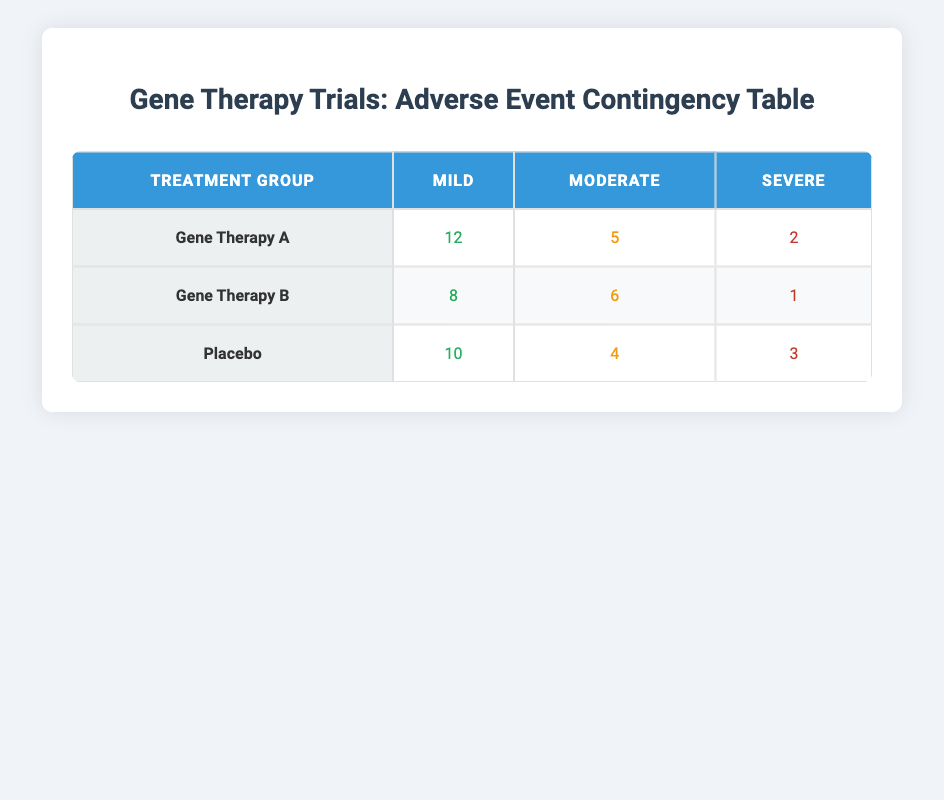What is the total number of mild adverse events in Gene Therapy A? Under the treatment group "Gene Therapy A," the table shows that the count of mild adverse events is 12. Therefore, the total number of mild adverse events for this treatment is simply the listed value of 12.
Answer: 12 Which treatment group had the highest number of severe adverse events? In the table, we see that Gene Therapy A has 2 severe adverse events, Gene Therapy B has 1 severe adverse event, and Placebo has 3 severe adverse events. Comparing these values, Placebo has the highest count of severe adverse events at 3.
Answer: Placebo What is the average number of moderate adverse events across all treatment groups? First, we sum the number of moderate adverse events: 5 (Gene Therapy A) + 6 (Gene Therapy B) + 4 (Placebo) = 15. There are 3 treatment groups, so the average is 15 divided by 3, which equals 5.
Answer: 5 Is it true that Gene Therapy B had fewer mild adverse events than Gene Therapy A? In the table, Gene Therapy A has 12 mild adverse events, while Gene Therapy B has 8 mild adverse events. Since 8 is less than 12, the statement is true.
Answer: Yes What is the total count of all adverse events for the Placebo group? To calculate the total for Placebo, we add the event counts: 10 (mild) + 4 (moderate) + 3 (severe) = 17. Therefore, the total count of all adverse events for the Placebo group is 17.
Answer: 17 How many more moderate adverse events does Gene Therapy B have compared to Gene Therapy A? Gene Therapy B has 6 moderate adverse events, while Gene Therapy A has 5. To find the difference, we subtract 5 from 6, resulting in 1. Therefore, Gene Therapy B has 1 more moderate adverse event than Gene Therapy A.
Answer: 1 What is the combined number of severe and moderate adverse events for Gene Therapy A? For Gene Therapy A, the moderate count is 5, and the severe count is 2. We add these two together: 5 + 2 = 7. Thus, the combined number of severe and moderate adverse events for Gene Therapy A is 7.
Answer: 7 